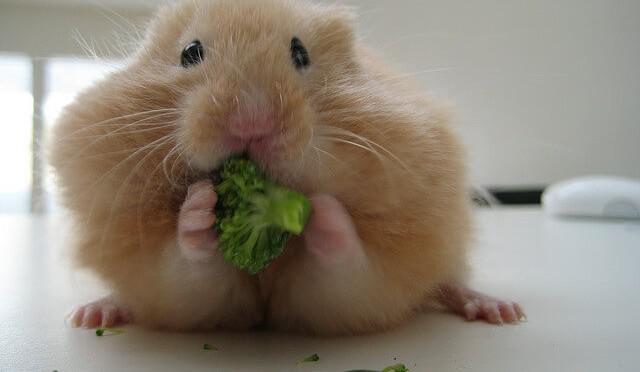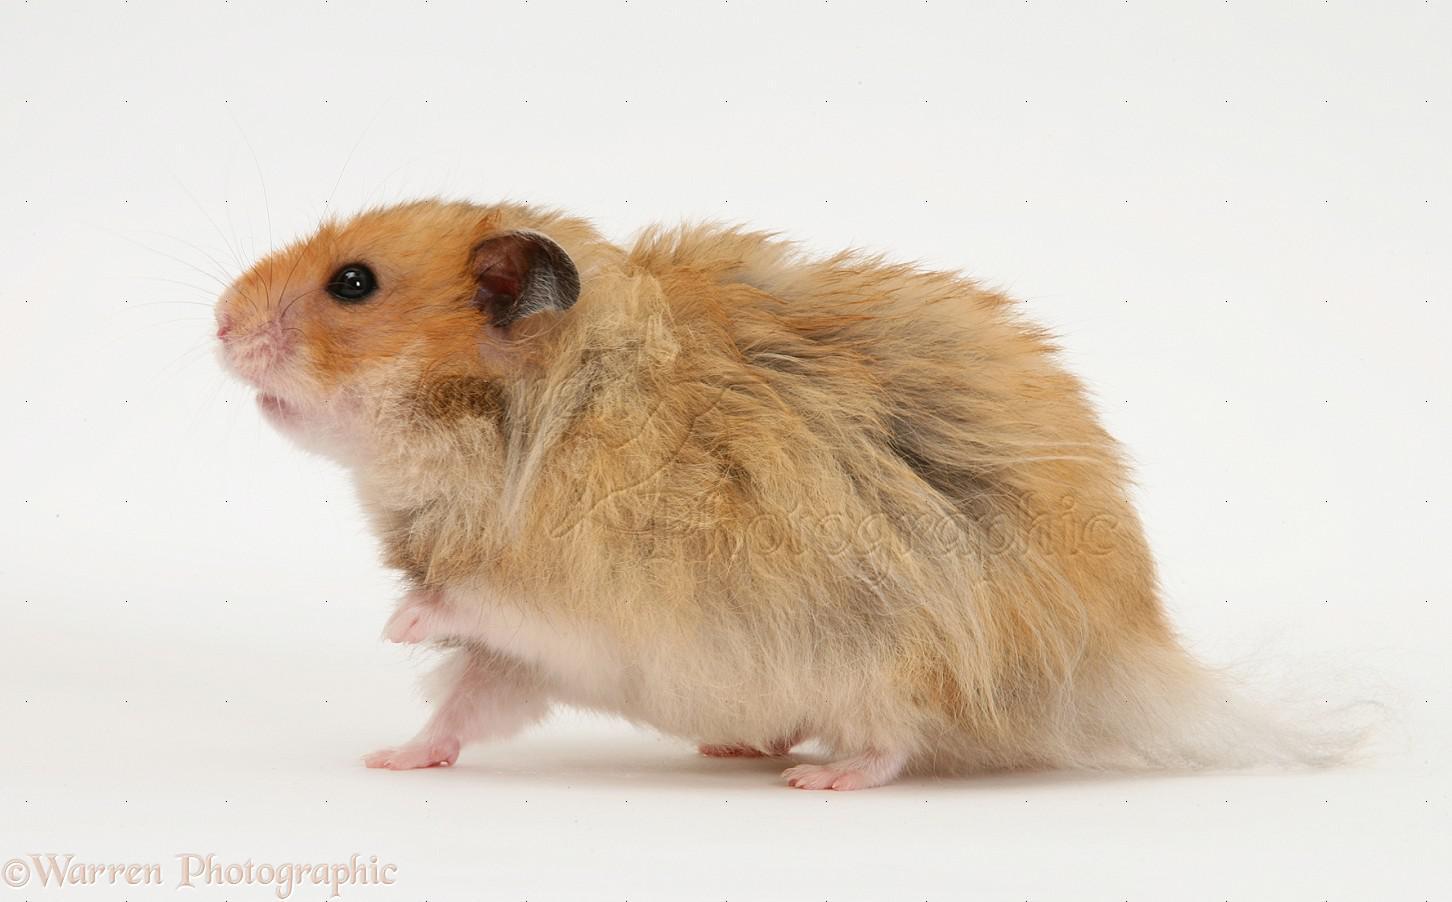The first image is the image on the left, the second image is the image on the right. Assess this claim about the two images: "There is a hamster eating a piece of broccoli.". Correct or not? Answer yes or no. Yes. The first image is the image on the left, the second image is the image on the right. For the images shown, is this caption "A light orange hamster is holding a broccoli floret to its mouth with both front paws." true? Answer yes or no. Yes. 